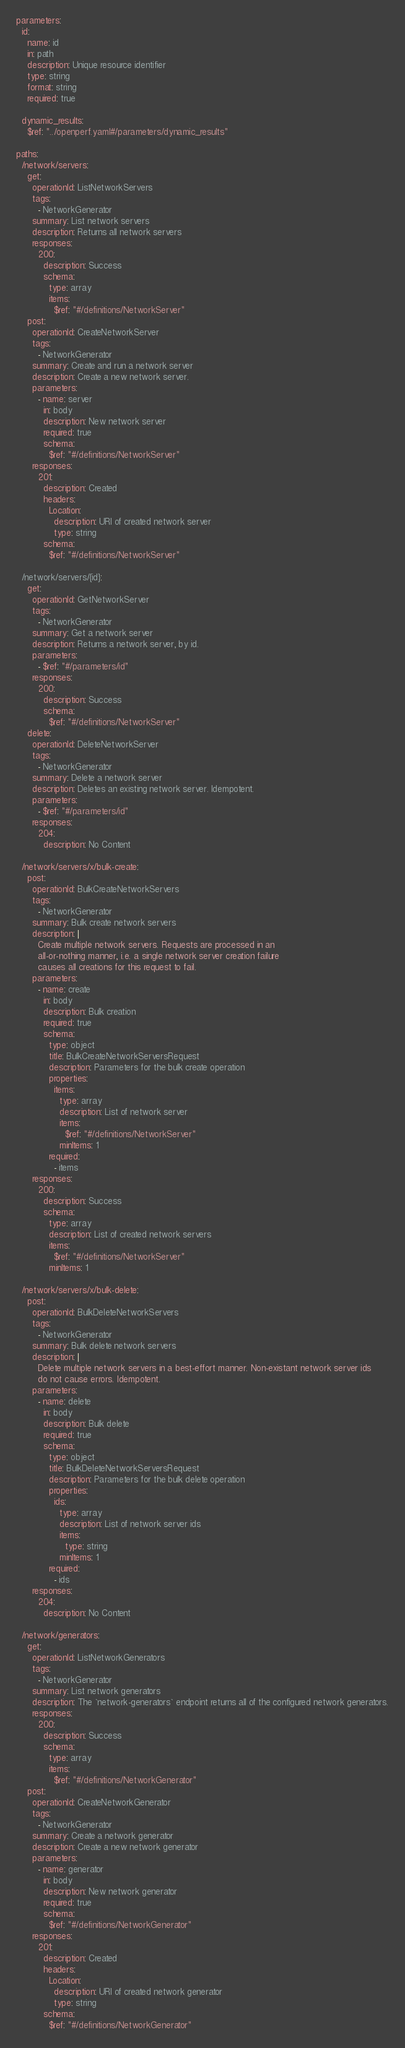<code> <loc_0><loc_0><loc_500><loc_500><_YAML_>parameters:
  id:
    name: id
    in: path
    description: Unique resource identifier
    type: string
    format: string
    required: true

  dynamic_results:
    $ref: "../openperf.yaml#/parameters/dynamic_results"

paths:
  /network/servers:
    get:
      operationId: ListNetworkServers
      tags:
        - NetworkGenerator
      summary: List network servers
      description: Returns all network servers
      responses:
        200:
          description: Success
          schema:
            type: array
            items:
              $ref: "#/definitions/NetworkServer"
    post:
      operationId: CreateNetworkServer
      tags:
        - NetworkGenerator
      summary: Create and run a network server
      description: Create a new network server.
      parameters:
        - name: server
          in: body
          description: New network server
          required: true
          schema:
            $ref: "#/definitions/NetworkServer"
      responses:
        201:
          description: Created
          headers:
            Location:
              description: URI of created network server
              type: string
          schema:
            $ref: "#/definitions/NetworkServer"

  /network/servers/{id}:
    get:
      operationId: GetNetworkServer
      tags:
        - NetworkGenerator
      summary: Get a network server
      description: Returns a network server, by id.
      parameters:
        - $ref: "#/parameters/id"
      responses:
        200:
          description: Success
          schema:
            $ref: "#/definitions/NetworkServer"
    delete:
      operationId: DeleteNetworkServer
      tags:
        - NetworkGenerator
      summary: Delete a network server
      description: Deletes an existing network server. Idempotent.
      parameters:
        - $ref: "#/parameters/id"
      responses:
        204:
          description: No Content

  /network/servers/x/bulk-create:
    post:
      operationId: BulkCreateNetworkServers
      tags:
        - NetworkGenerator
      summary: Bulk create network servers
      description: |
        Create multiple network servers. Requests are processed in an
        all-or-nothing manner, i.e. a single network server creation failure
        causes all creations for this request to fail.
      parameters:
        - name: create
          in: body
          description: Bulk creation
          required: true
          schema:
            type: object
            title: BulkCreateNetworkServersRequest
            description: Parameters for the bulk create operation
            properties:
              items:
                type: array
                description: List of network server
                items:
                  $ref: "#/definitions/NetworkServer"
                minItems: 1
            required:
              - items
      responses:
        200:
          description: Success
          schema:
            type: array
            description: List of created network servers
            items:
              $ref: "#/definitions/NetworkServer"
            minItems: 1

  /network/servers/x/bulk-delete:
    post:
      operationId: BulkDeleteNetworkServers
      tags:
        - NetworkGenerator
      summary: Bulk delete network servers
      description: |
        Delete multiple network servers in a best-effort manner. Non-existant network server ids
        do not cause errors. Idempotent.
      parameters:
        - name: delete
          in: body
          description: Bulk delete
          required: true
          schema:
            type: object
            title: BulkDeleteNetworkServersRequest
            description: Parameters for the bulk delete operation
            properties:
              ids:
                type: array
                description: List of network server ids
                items:
                  type: string
                minItems: 1
            required:
              - ids
      responses:
        204:
          description: No Content

  /network/generators:
    get:
      operationId: ListNetworkGenerators
      tags:
        - NetworkGenerator
      summary: List network generators
      description: The `network-generators` endpoint returns all of the configured network generators.
      responses:
        200:
          description: Success
          schema:
            type: array
            items:
              $ref: "#/definitions/NetworkGenerator"
    post:
      operationId: CreateNetworkGenerator
      tags:
        - NetworkGenerator
      summary: Create a network generator
      description: Create a new network generator
      parameters:
        - name: generator
          in: body
          description: New network generator
          required: true
          schema:
            $ref: "#/definitions/NetworkGenerator"
      responses:
        201:
          description: Created
          headers:
            Location:
              description: URI of created network generator
              type: string
          schema:
            $ref: "#/definitions/NetworkGenerator"
</code> 